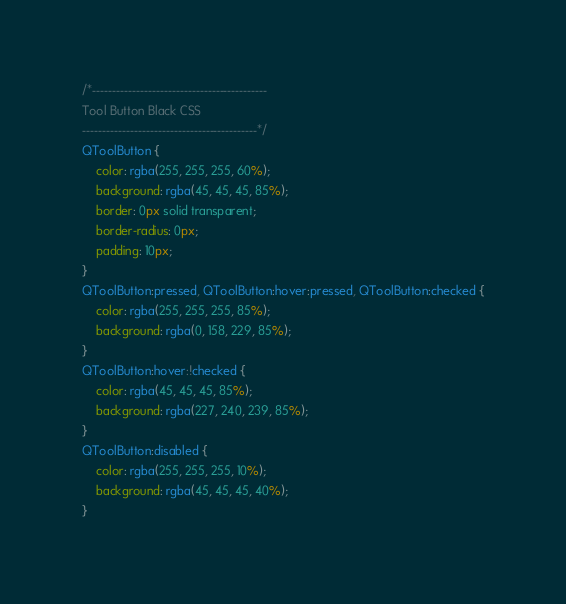<code> <loc_0><loc_0><loc_500><loc_500><_CSS_>/*-------------------------------------------- 
Tool Button Black CSS
--------------------------------------------*/
QToolButton {
    color: rgba(255, 255, 255, 60%);
    background: rgba(45, 45, 45, 85%);
    border: 0px solid transparent;
    border-radius: 0px;
    padding: 10px;
}
QToolButton:pressed, QToolButton:hover:pressed, QToolButton:checked {
    color: rgba(255, 255, 255, 85%);
    background: rgba(0, 158, 229, 85%);
}
QToolButton:hover:!checked {
    color: rgba(45, 45, 45, 85%);
    background: rgba(227, 240, 239, 85%);
}
QToolButton:disabled {
    color: rgba(255, 255, 255, 10%);
    background: rgba(45, 45, 45, 40%);
}
</code> 